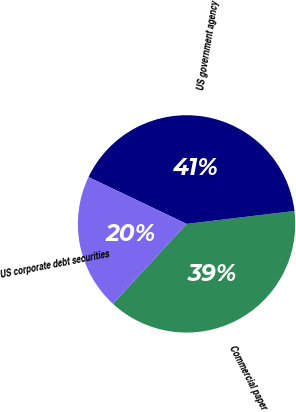Convert chart. <chart><loc_0><loc_0><loc_500><loc_500><pie_chart><fcel>Commercial paper<fcel>US government agency<fcel>US corporate debt securities<nl><fcel>38.75%<fcel>41.02%<fcel>20.24%<nl></chart> 